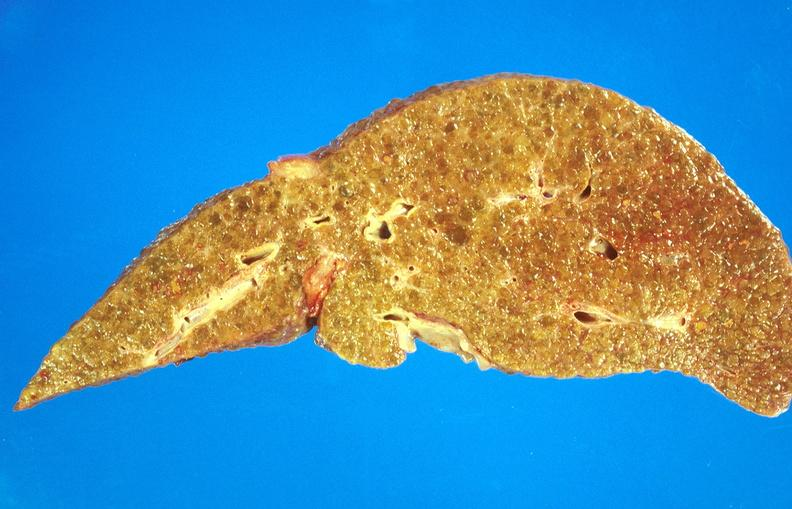s nuclear change present?
Answer the question using a single word or phrase. No 